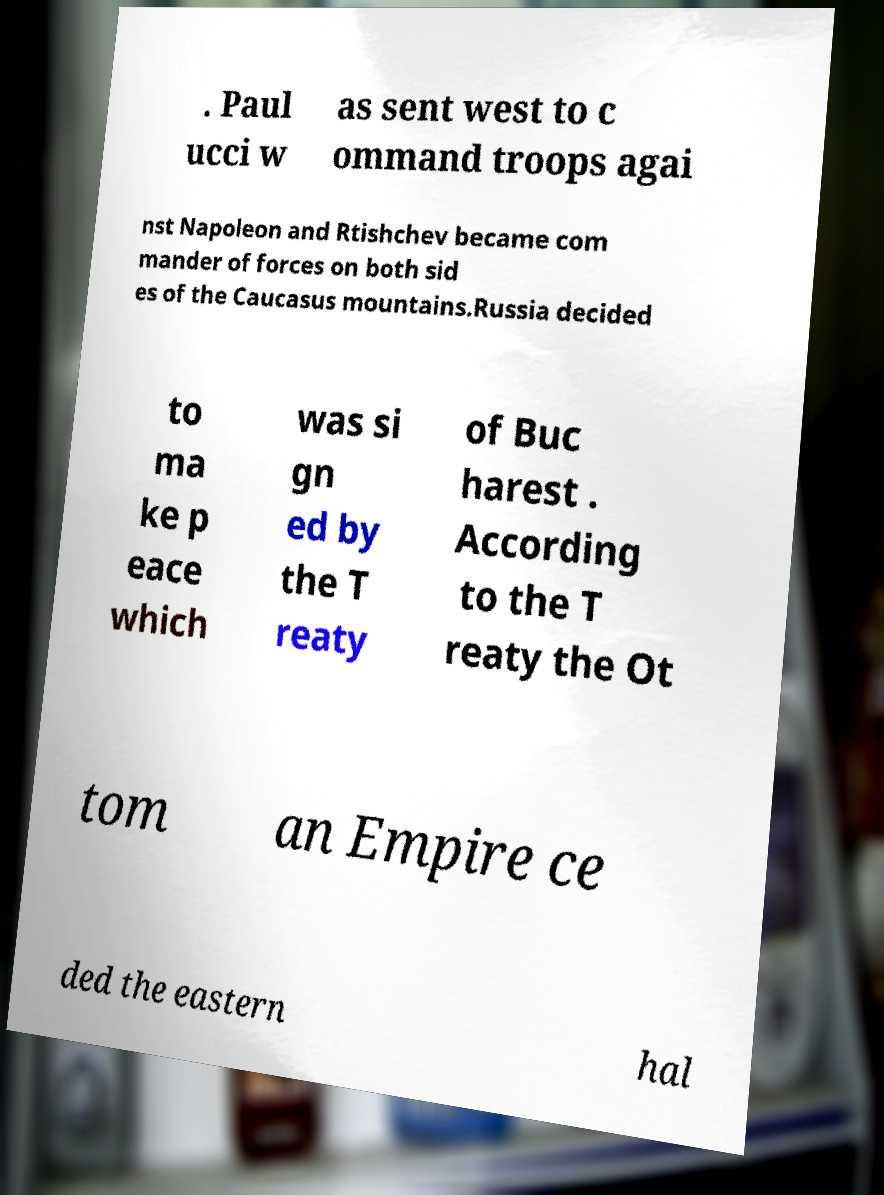There's text embedded in this image that I need extracted. Can you transcribe it verbatim? . Paul ucci w as sent west to c ommand troops agai nst Napoleon and Rtishchev became com mander of forces on both sid es of the Caucasus mountains.Russia decided to ma ke p eace which was si gn ed by the T reaty of Buc harest . According to the T reaty the Ot tom an Empire ce ded the eastern hal 